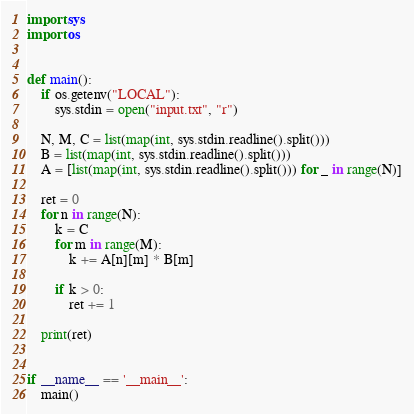<code> <loc_0><loc_0><loc_500><loc_500><_Python_>import sys
import os


def main():
    if os.getenv("LOCAL"):
        sys.stdin = open("input.txt", "r")

    N, M, C = list(map(int, sys.stdin.readline().split()))
    B = list(map(int, sys.stdin.readline().split()))
    A = [list(map(int, sys.stdin.readline().split())) for _ in range(N)]

    ret = 0
    for n in range(N):
        k = C
        for m in range(M):
            k += A[n][m] * B[m]

        if k > 0:
            ret += 1

    print(ret)


if __name__ == '__main__':
    main()
</code> 